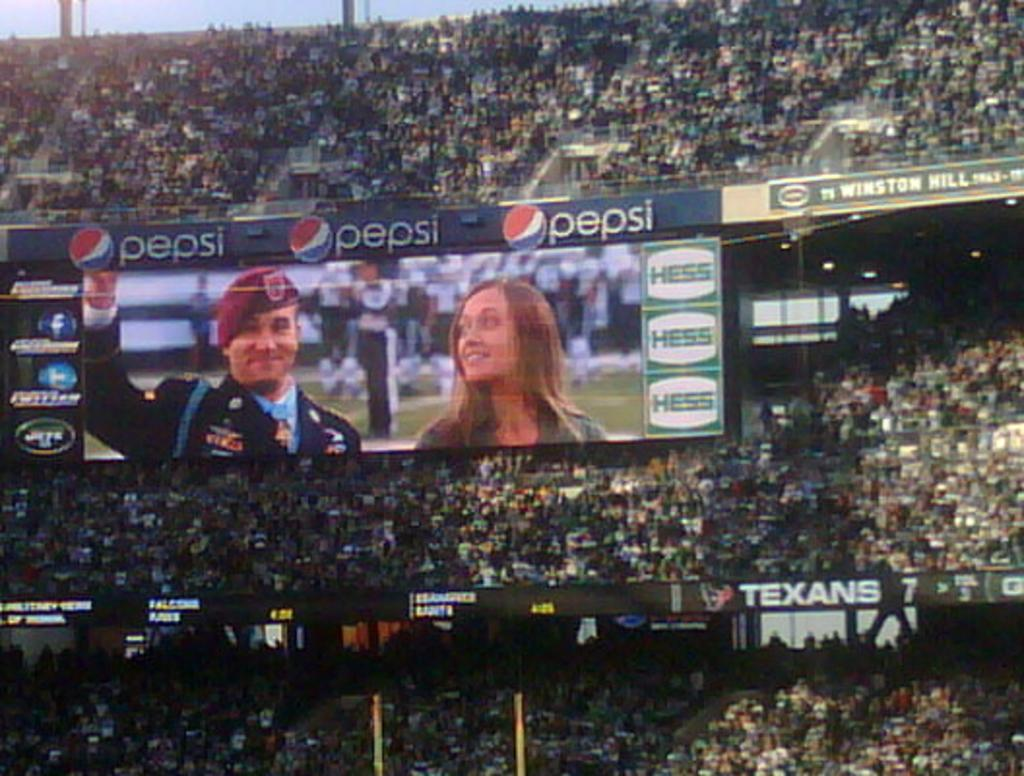<image>
Give a short and clear explanation of the subsequent image. A stadium full of people sponsored by Pepsi and Hess. 